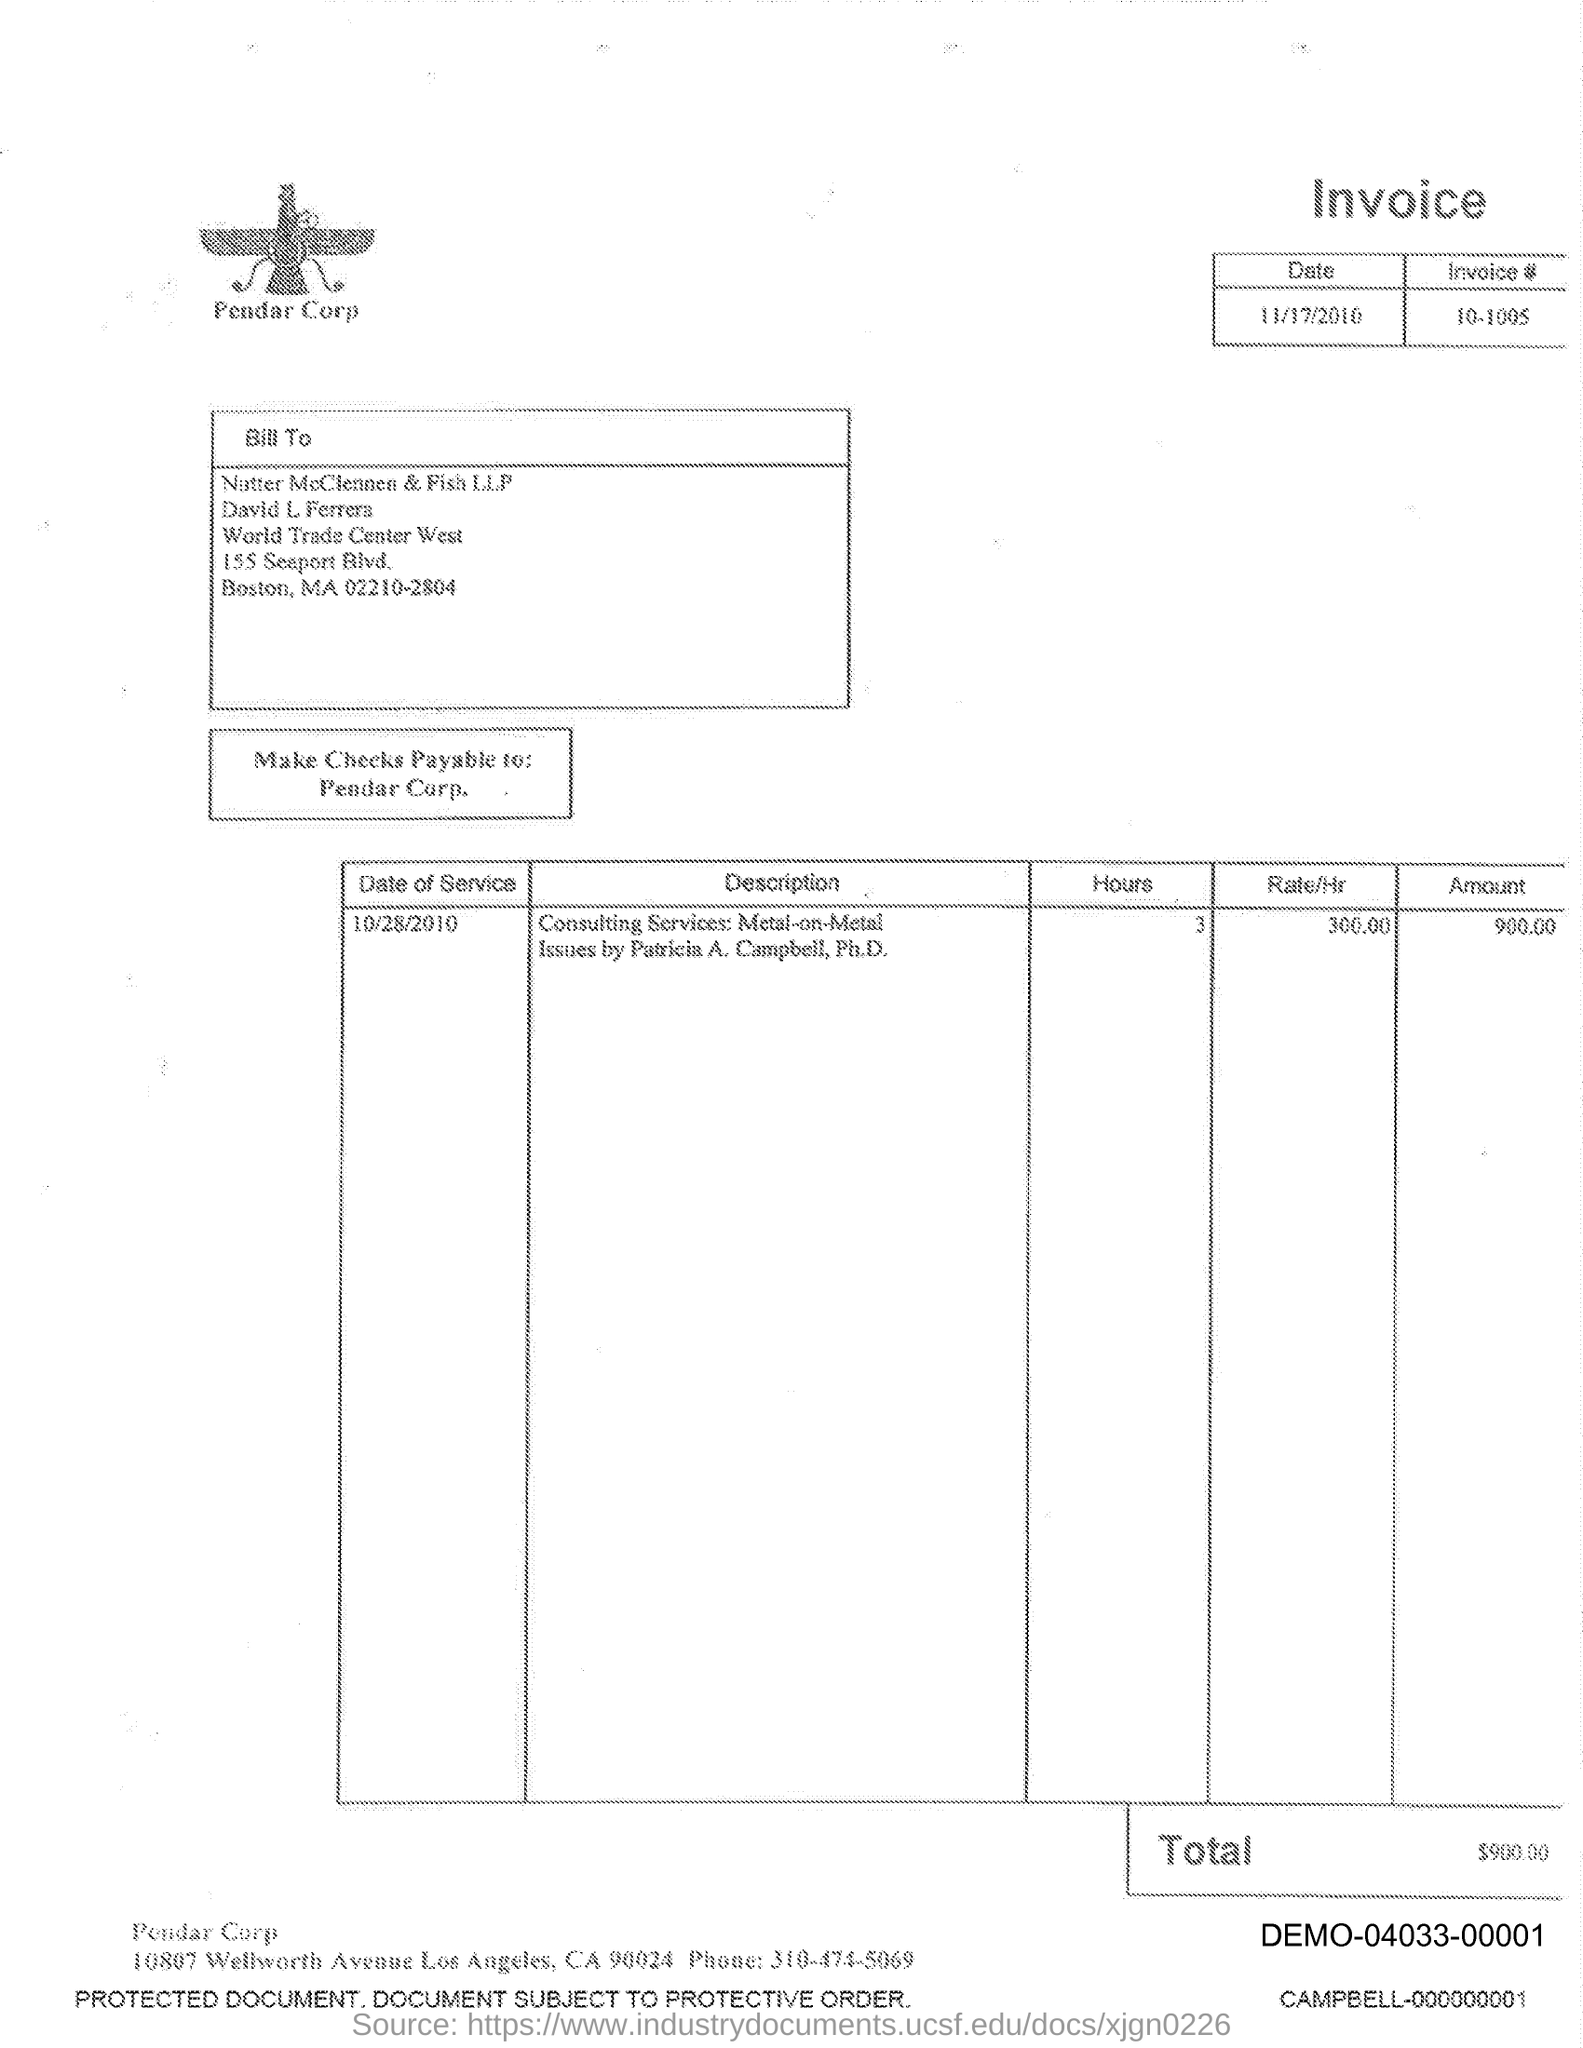What is the text written below the image?
Offer a very short reply. Pendar Corp. 